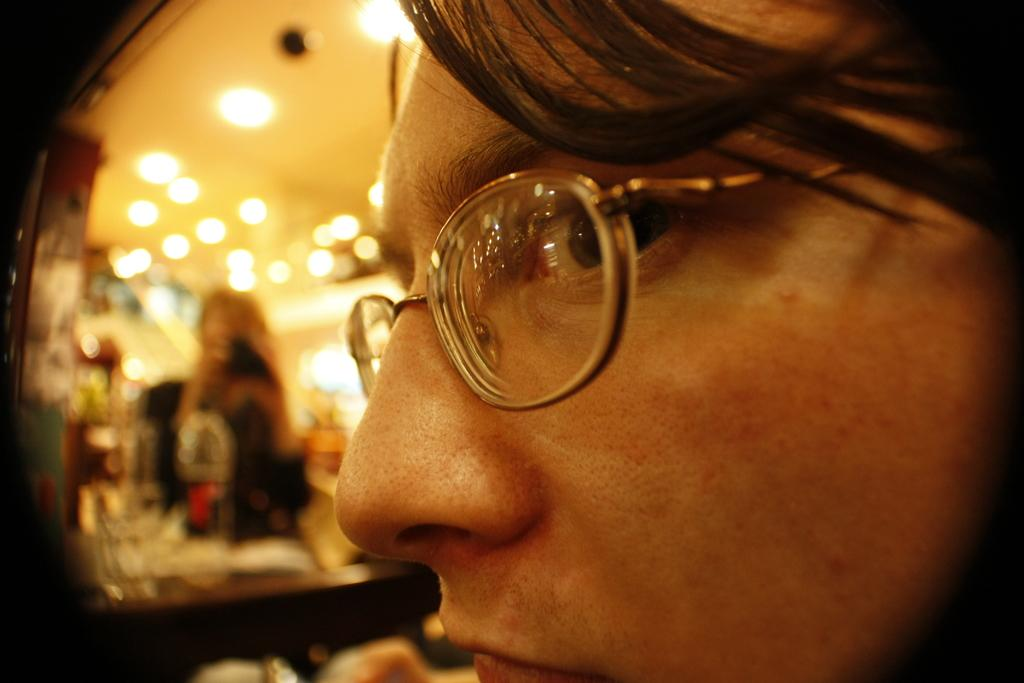Who is present in the image? There is a woman in the image. What is the woman wearing? The woman is wearing spectacles. What object is present in the image that can be used for self-reflection? There is a mirror in the image. What can be seen in the mirror reflection? The mirror reflection shows a woman holding a camera. What type of vessel is being used by the police in the image? There is no vessel or police present in the image. 